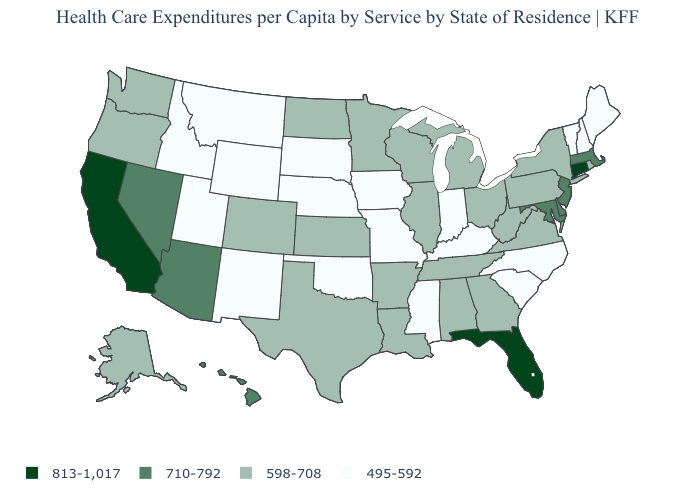How many symbols are there in the legend?
Write a very short answer. 4. Among the states that border New York , which have the lowest value?
Keep it brief. Vermont. What is the lowest value in states that border Arizona?
Quick response, please. 495-592. What is the value of North Carolina?
Give a very brief answer. 495-592. What is the value of Illinois?
Keep it brief. 598-708. Does Kentucky have the highest value in the USA?
Short answer required. No. Among the states that border Ohio , which have the highest value?
Be succinct. Michigan, Pennsylvania, West Virginia. What is the value of Pennsylvania?
Write a very short answer. 598-708. Among the states that border Missouri , which have the lowest value?
Short answer required. Iowa, Kentucky, Nebraska, Oklahoma. Is the legend a continuous bar?
Give a very brief answer. No. What is the value of Tennessee?
Concise answer only. 598-708. Which states hav the highest value in the West?
Answer briefly. California. What is the highest value in the USA?
Be succinct. 813-1,017. Name the states that have a value in the range 813-1,017?
Keep it brief. California, Connecticut, Florida. Which states have the highest value in the USA?
Be succinct. California, Connecticut, Florida. 